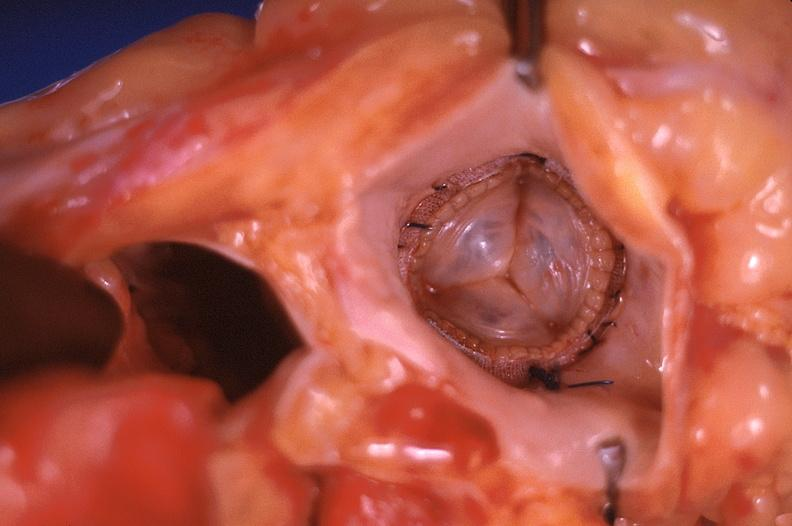what is present?
Answer the question using a single word or phrase. Cardiovascular 